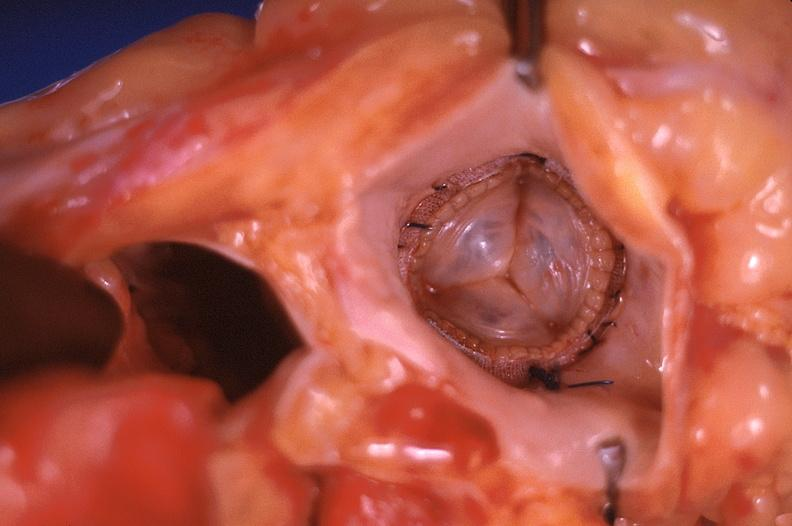what is present?
Answer the question using a single word or phrase. Cardiovascular 